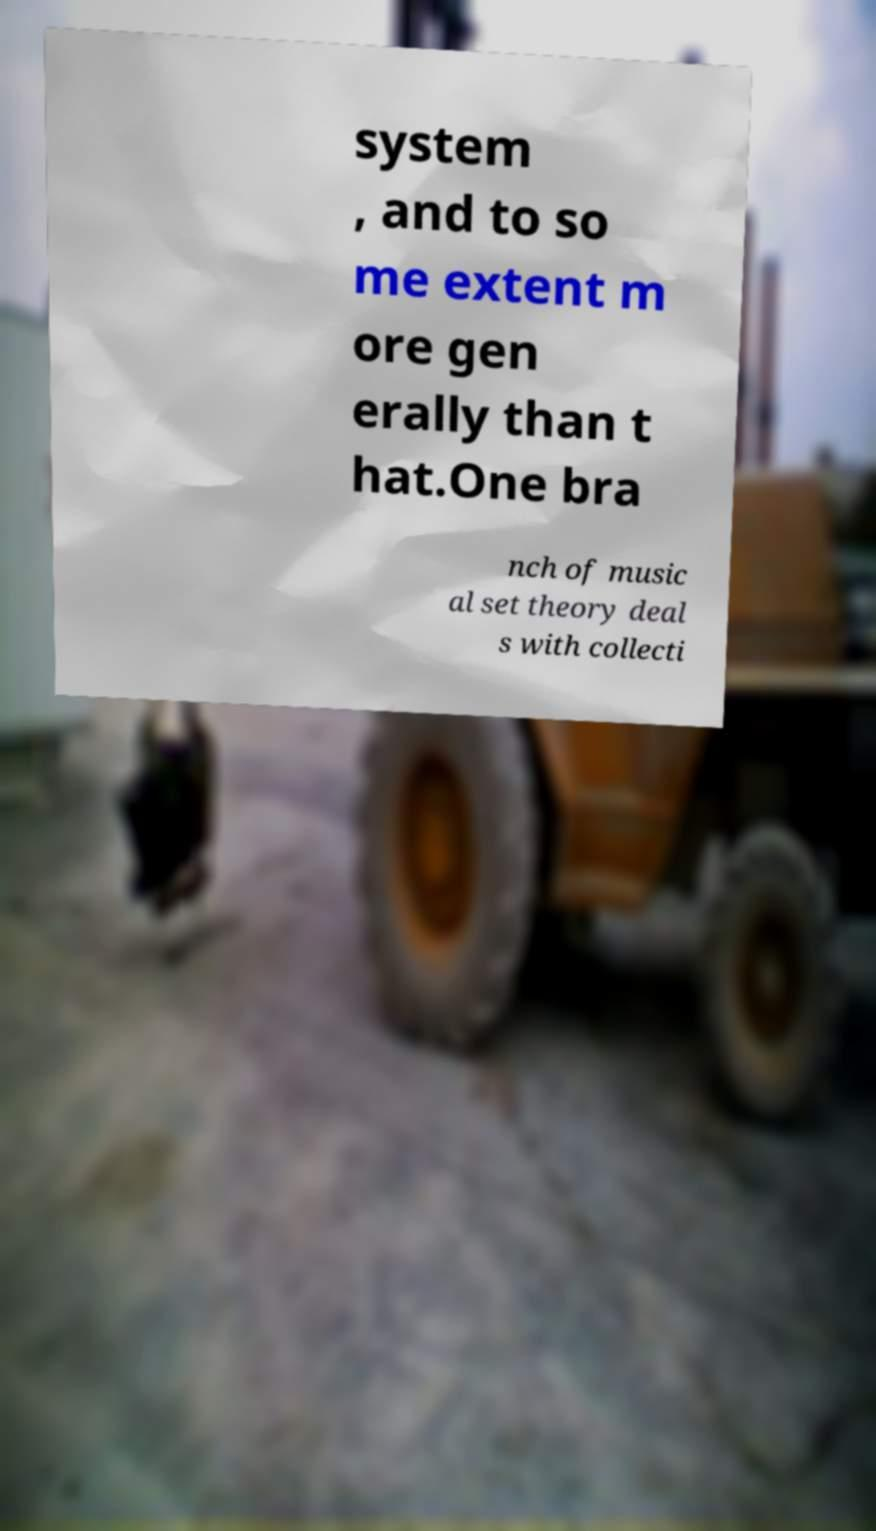Can you read and provide the text displayed in the image?This photo seems to have some interesting text. Can you extract and type it out for me? system , and to so me extent m ore gen erally than t hat.One bra nch of music al set theory deal s with collecti 